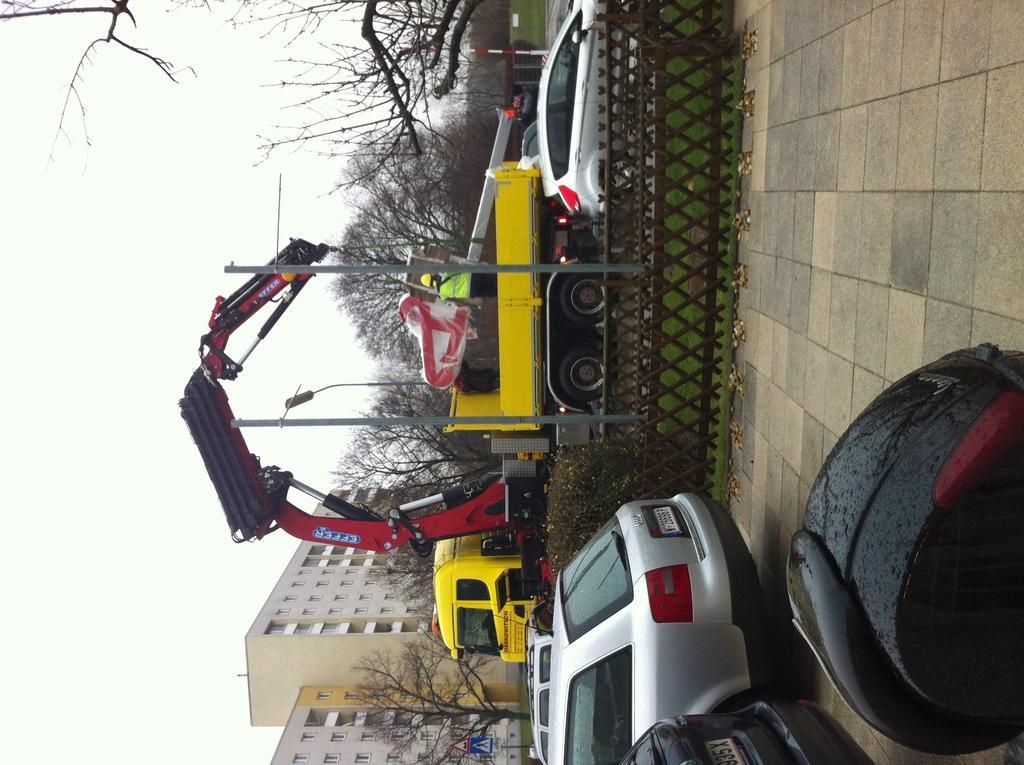Can you describe this image briefly? In this image there are vehicles on the floor. There is a fence. Behind there are plants on the grassland having poles. Behind there are vehicles. Middle of the image there is a street light. Background there are trees and buildings. Left side there is sky. 